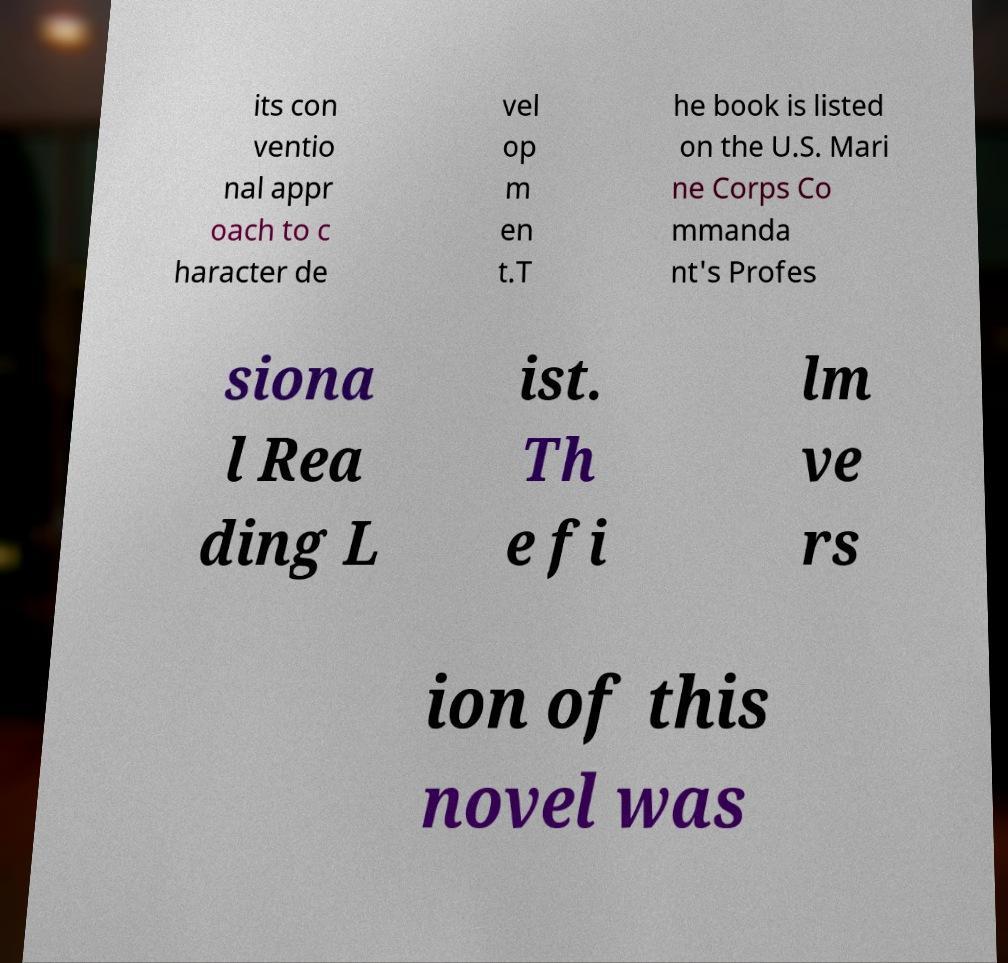There's text embedded in this image that I need extracted. Can you transcribe it verbatim? its con ventio nal appr oach to c haracter de vel op m en t.T he book is listed on the U.S. Mari ne Corps Co mmanda nt's Profes siona l Rea ding L ist. Th e fi lm ve rs ion of this novel was 